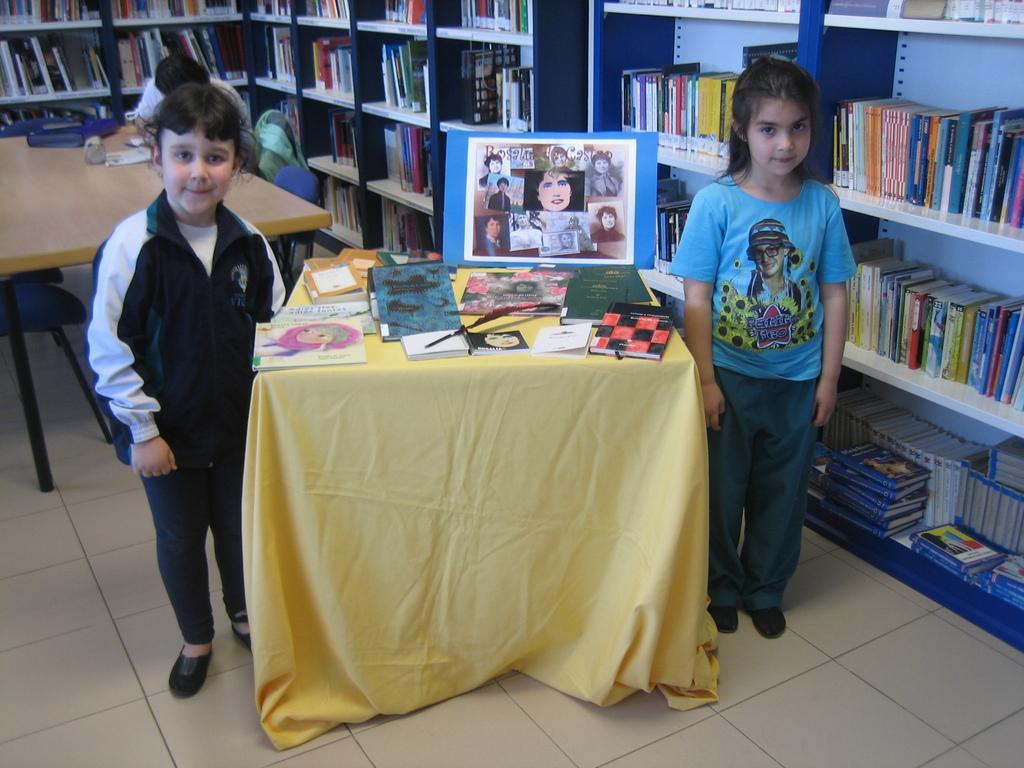In one or two sentences, can you explain what this image depicts? This picture is taken in the library. The kid standing at the right side is wearing a blue colour t-shirt. In the center the table is covered with a yellow coloured cloth. On the table there are books, photo frame. At the left side the kid is wearing a black colour jacket. In the background there is a table and chairs, person sitting on the chair. There is the shelves and books are filled in the shelves. 